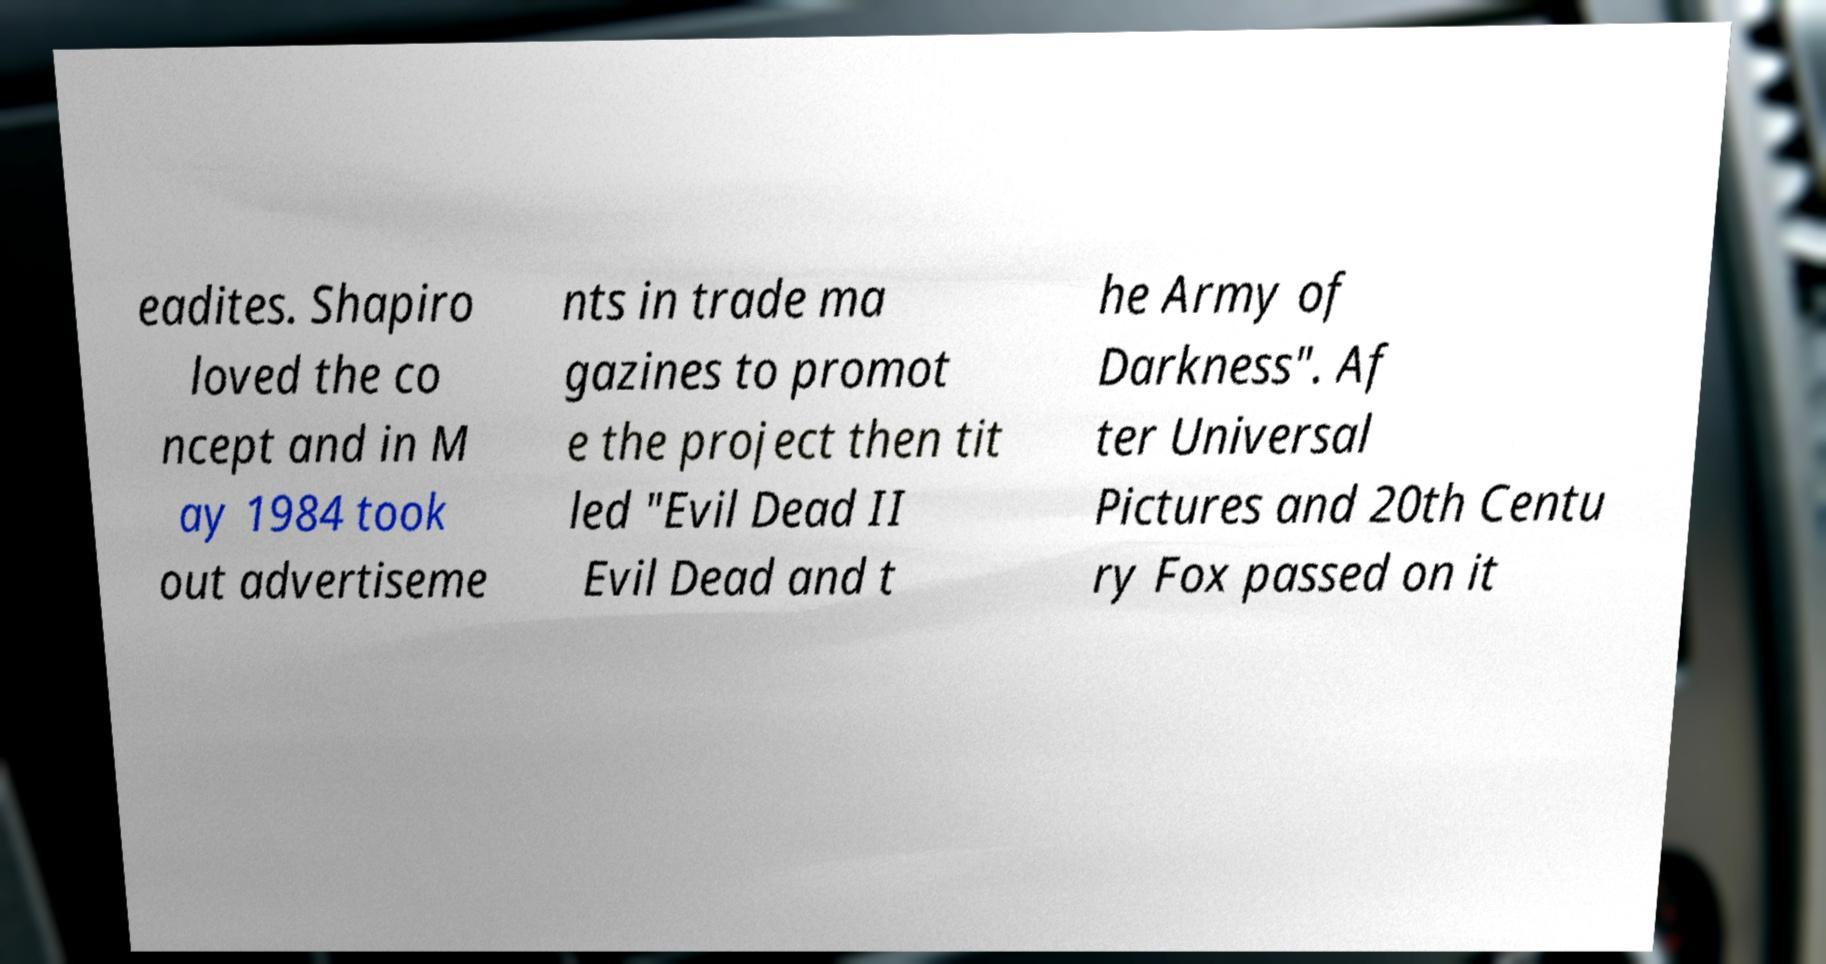Could you extract and type out the text from this image? eadites. Shapiro loved the co ncept and in M ay 1984 took out advertiseme nts in trade ma gazines to promot e the project then tit led "Evil Dead II Evil Dead and t he Army of Darkness". Af ter Universal Pictures and 20th Centu ry Fox passed on it 